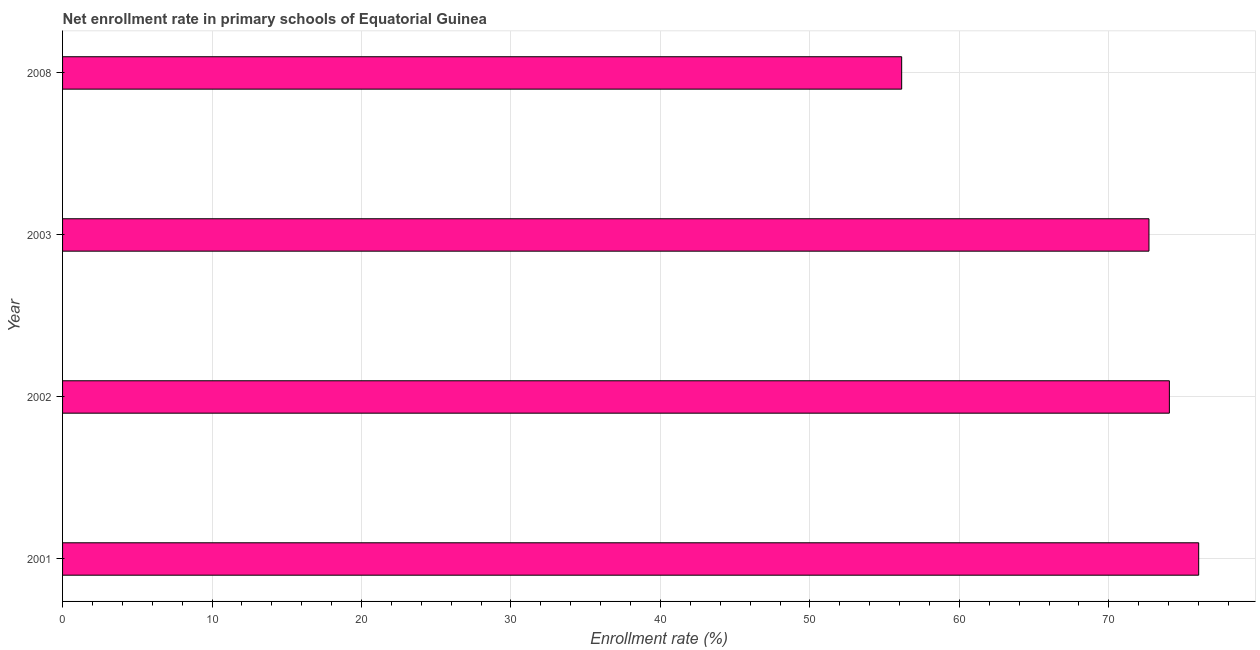Does the graph contain any zero values?
Make the answer very short. No. Does the graph contain grids?
Provide a short and direct response. Yes. What is the title of the graph?
Provide a succinct answer. Net enrollment rate in primary schools of Equatorial Guinea. What is the label or title of the X-axis?
Make the answer very short. Enrollment rate (%). What is the label or title of the Y-axis?
Offer a very short reply. Year. What is the net enrollment rate in primary schools in 2003?
Your answer should be compact. 72.68. Across all years, what is the maximum net enrollment rate in primary schools?
Ensure brevity in your answer.  76.01. Across all years, what is the minimum net enrollment rate in primary schools?
Offer a terse response. 56.14. In which year was the net enrollment rate in primary schools minimum?
Ensure brevity in your answer.  2008. What is the sum of the net enrollment rate in primary schools?
Give a very brief answer. 278.87. What is the difference between the net enrollment rate in primary schools in 2001 and 2003?
Give a very brief answer. 3.33. What is the average net enrollment rate in primary schools per year?
Give a very brief answer. 69.72. What is the median net enrollment rate in primary schools?
Offer a terse response. 73.36. Do a majority of the years between 2002 and 2008 (inclusive) have net enrollment rate in primary schools greater than 52 %?
Offer a terse response. Yes. What is the ratio of the net enrollment rate in primary schools in 2001 to that in 2008?
Ensure brevity in your answer.  1.35. Is the net enrollment rate in primary schools in 2003 less than that in 2008?
Provide a succinct answer. No. Is the difference between the net enrollment rate in primary schools in 2001 and 2003 greater than the difference between any two years?
Offer a terse response. No. What is the difference between the highest and the second highest net enrollment rate in primary schools?
Provide a succinct answer. 1.96. What is the difference between the highest and the lowest net enrollment rate in primary schools?
Your answer should be compact. 19.87. Are all the bars in the graph horizontal?
Provide a succinct answer. Yes. How many years are there in the graph?
Offer a terse response. 4. What is the Enrollment rate (%) of 2001?
Give a very brief answer. 76.01. What is the Enrollment rate (%) in 2002?
Keep it short and to the point. 74.05. What is the Enrollment rate (%) in 2003?
Your answer should be very brief. 72.68. What is the Enrollment rate (%) of 2008?
Your response must be concise. 56.14. What is the difference between the Enrollment rate (%) in 2001 and 2002?
Your answer should be compact. 1.96. What is the difference between the Enrollment rate (%) in 2001 and 2003?
Ensure brevity in your answer.  3.33. What is the difference between the Enrollment rate (%) in 2001 and 2008?
Your response must be concise. 19.87. What is the difference between the Enrollment rate (%) in 2002 and 2003?
Provide a short and direct response. 1.37. What is the difference between the Enrollment rate (%) in 2002 and 2008?
Keep it short and to the point. 17.91. What is the difference between the Enrollment rate (%) in 2003 and 2008?
Your answer should be very brief. 16.54. What is the ratio of the Enrollment rate (%) in 2001 to that in 2003?
Provide a succinct answer. 1.05. What is the ratio of the Enrollment rate (%) in 2001 to that in 2008?
Provide a short and direct response. 1.35. What is the ratio of the Enrollment rate (%) in 2002 to that in 2008?
Offer a very short reply. 1.32. What is the ratio of the Enrollment rate (%) in 2003 to that in 2008?
Your response must be concise. 1.29. 